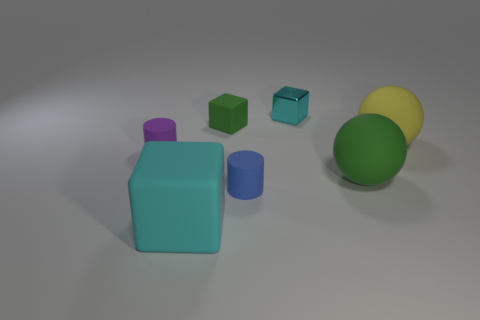Add 1 large metallic cubes. How many objects exist? 8 Subtract all cyan cubes. How many cubes are left? 1 Subtract 2 balls. How many balls are left? 0 Subtract all yellow balls. How many balls are left? 1 Subtract 1 blue cylinders. How many objects are left? 6 Subtract all blocks. How many objects are left? 4 Subtract all gray blocks. Subtract all yellow balls. How many blocks are left? 3 Subtract all red cylinders. How many blue spheres are left? 0 Subtract all tiny blue matte things. Subtract all purple rubber objects. How many objects are left? 5 Add 7 matte blocks. How many matte blocks are left? 9 